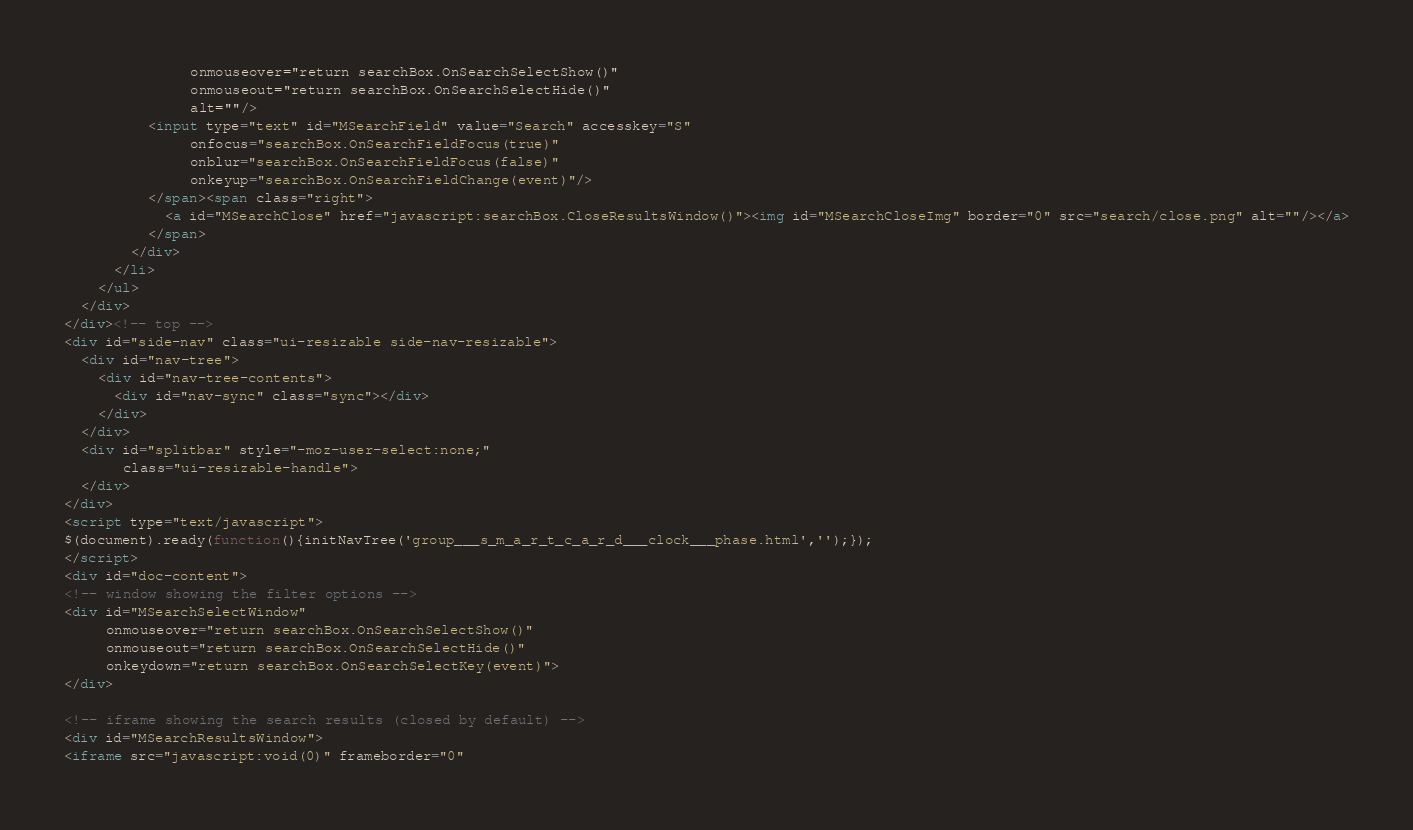Convert code to text. <code><loc_0><loc_0><loc_500><loc_500><_HTML_>               onmouseover="return searchBox.OnSearchSelectShow()"
               onmouseout="return searchBox.OnSearchSelectHide()"
               alt=""/>
          <input type="text" id="MSearchField" value="Search" accesskey="S"
               onfocus="searchBox.OnSearchFieldFocus(true)" 
               onblur="searchBox.OnSearchFieldFocus(false)" 
               onkeyup="searchBox.OnSearchFieldChange(event)"/>
          </span><span class="right">
            <a id="MSearchClose" href="javascript:searchBox.CloseResultsWindow()"><img id="MSearchCloseImg" border="0" src="search/close.png" alt=""/></a>
          </span>
        </div>
      </li>
    </ul>
  </div>
</div><!-- top -->
<div id="side-nav" class="ui-resizable side-nav-resizable">
  <div id="nav-tree">
    <div id="nav-tree-contents">
      <div id="nav-sync" class="sync"></div>
    </div>
  </div>
  <div id="splitbar" style="-moz-user-select:none;" 
       class="ui-resizable-handle">
  </div>
</div>
<script type="text/javascript">
$(document).ready(function(){initNavTree('group___s_m_a_r_t_c_a_r_d___clock___phase.html','');});
</script>
<div id="doc-content">
<!-- window showing the filter options -->
<div id="MSearchSelectWindow"
     onmouseover="return searchBox.OnSearchSelectShow()"
     onmouseout="return searchBox.OnSearchSelectHide()"
     onkeydown="return searchBox.OnSearchSelectKey(event)">
</div>

<!-- iframe showing the search results (closed by default) -->
<div id="MSearchResultsWindow">
<iframe src="javascript:void(0)" frameborder="0" </code> 